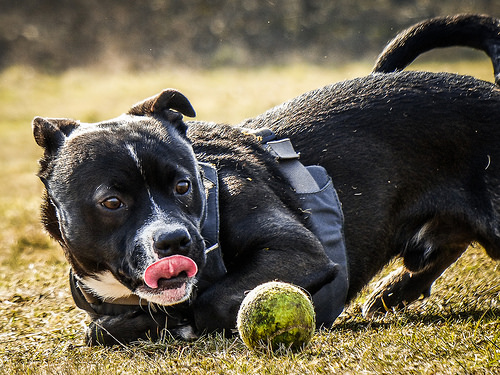<image>
Is the ball next to the dog? Yes. The ball is positioned adjacent to the dog, located nearby in the same general area. Is there a dog next to the ball? Yes. The dog is positioned adjacent to the ball, located nearby in the same general area. 